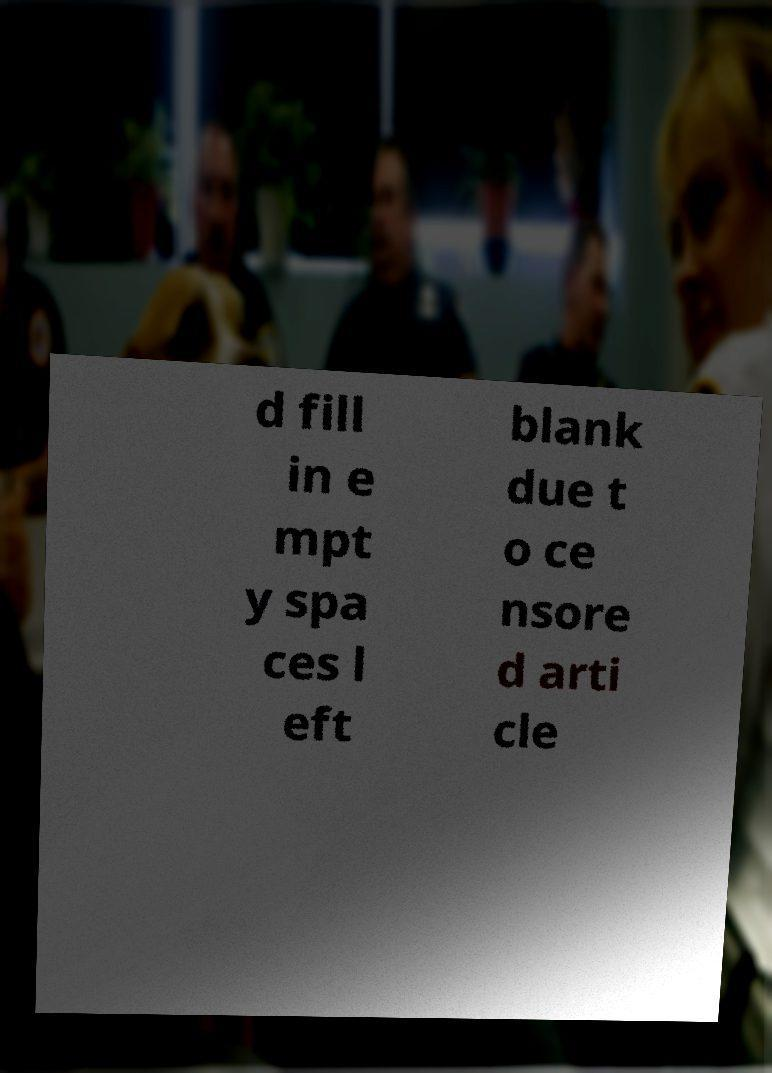Can you read and provide the text displayed in the image?This photo seems to have some interesting text. Can you extract and type it out for me? d fill in e mpt y spa ces l eft blank due t o ce nsore d arti cle 